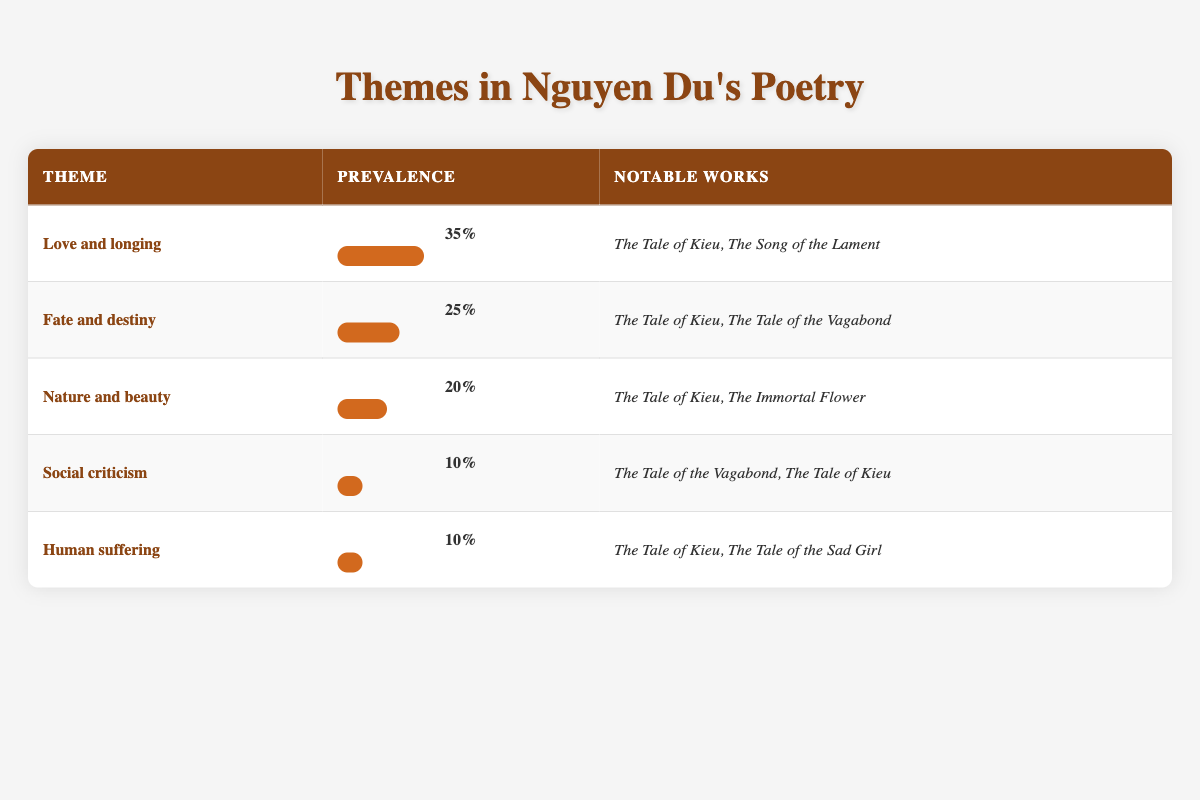What is the theme with the highest prevalence? The theme with the highest prevalence can be found by scanning through the prevalence percentages in the table. "Love and longing" has the highest percentage at 35%.
Answer: Love and longing Which notable work is associated with the theme of fate and destiny? Referring to the notable works listed for the theme of fate and destiny, "The Tale of Kieu" is one of the associated works.
Answer: The Tale of Kieu What is the prevalence percentage of social criticism? The prevalence percentage for social criticism is indicated directly in the table under the prevalence column. It states 10%.
Answer: 10% If we combine the prevalence percentages of human suffering and social criticism, what do we get? To find the combined prevalence, sum the percentages of both themes: 10% (human suffering) + 10% (social criticism) = 20%.
Answer: 20% Does the theme of nature and beauty have a prevalence percentage greater than 15%? Checking the prevalence percentage for nature and beauty, which is noted as 20%, confirms that it is indeed greater than 15%.
Answer: Yes What percentage of the themes focus on love, fate, and nature combined? To calculate the combined percentage, add their prevalence percentages: 35% (love and longing) + 25% (fate and destiny) + 20% (nature and beauty) = 80%.
Answer: 80% How many themes have a prevalence of 10%? By examining the table, there are two themes, "Social criticism" and "Human suffering," that have a prevalence of 10%.
Answer: 2 Is "The Tale of Kieu" associated with more than three themes listed in the table? The table shows that "The Tale of Kieu" is linked to four themes: love and longing, fate and destiny, nature and beauty, and social criticism. Thus, it is associated with more than three.
Answer: Yes 